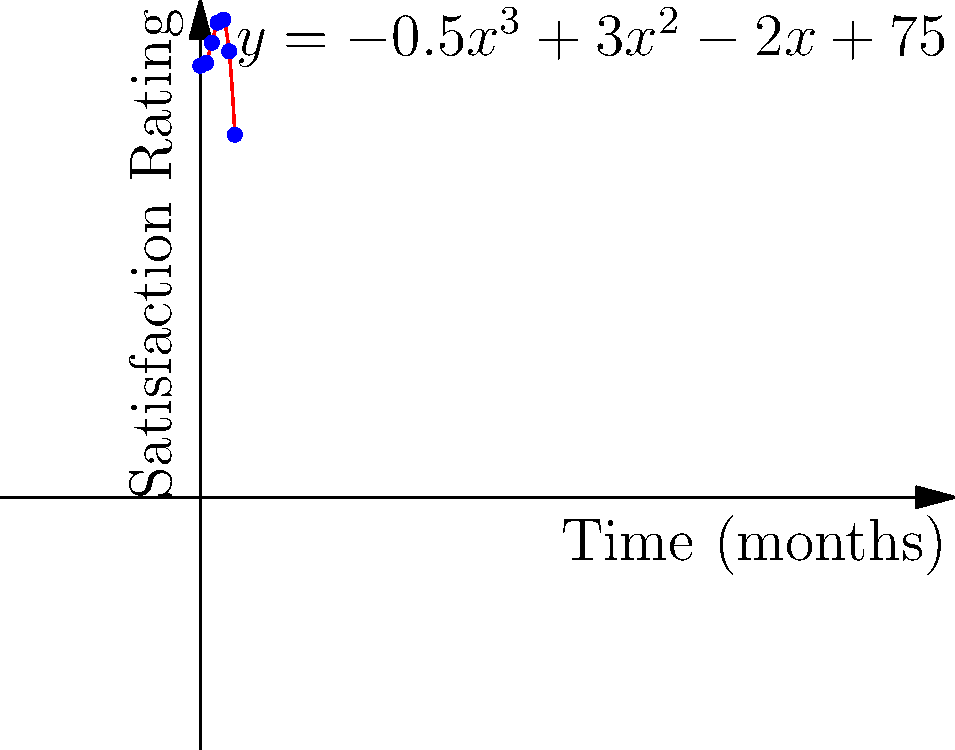As a flight attendant concerned with working conditions, you've been tracking passenger satisfaction ratings over the past 6 months. The data can be modeled by the polynomial function $y = -0.5x^3 + 3x^2 - 2x + 75$, where $x$ represents the number of months and $y$ represents the satisfaction rating. At which month does the satisfaction rating reach its peak? To find the month when the satisfaction rating reaches its peak, we need to follow these steps:

1) The peak of the function occurs at the maximum point of the curve.

2) To find the maximum point, we need to find where the derivative of the function equals zero:
   $\frac{dy}{dx} = -1.5x^2 + 6x - 2$

3) Set the derivative to zero and solve:
   $-1.5x^2 + 6x - 2 = 0$
   
4) This is a quadratic equation. We can solve it using the quadratic formula:
   $x = \frac{-b \pm \sqrt{b^2 - 4ac}}{2a}$
   
   Where $a=-1.5$, $b=6$, and $c=-2$

5) Plugging in these values:
   $x = \frac{-6 \pm \sqrt{36 - 4(-1.5)(-2)}}{2(-1.5)}$
   $= \frac{-6 \pm \sqrt{36 - 12}}{-3}$
   $= \frac{-6 \pm \sqrt{24}}{-3}$
   $= \frac{-6 \pm 4.9}{-3}$

6) This gives us two solutions:
   $x_1 = \frac{-6 + 4.9}{-3} \approx 0.37$
   $x_2 = \frac{-6 - 4.9}{-3} \approx 3.63$

7) Since we're looking for a maximum (not a minimum), and the leading coefficient of our original function is negative (indicating it opens downward), we choose the larger value: 3.63.

8) As we're dealing with discrete months, we round this to the nearest whole number: 4.

Therefore, the satisfaction rating reaches its peak at month 4.
Answer: 4 months 